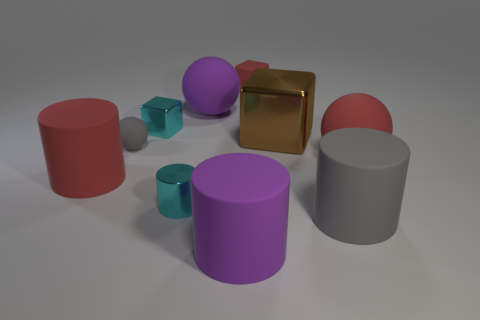How do the colors in the image contribute to its overall feel? The mix of pastel and muted colors, such as the soft purple and red, with the more vibrant touches like the teal, create a balanced and harmonious composition. They lend the image a modern and clean aesthetic that's pleasing to the eye and suggest a non-threatening, serene setting. 